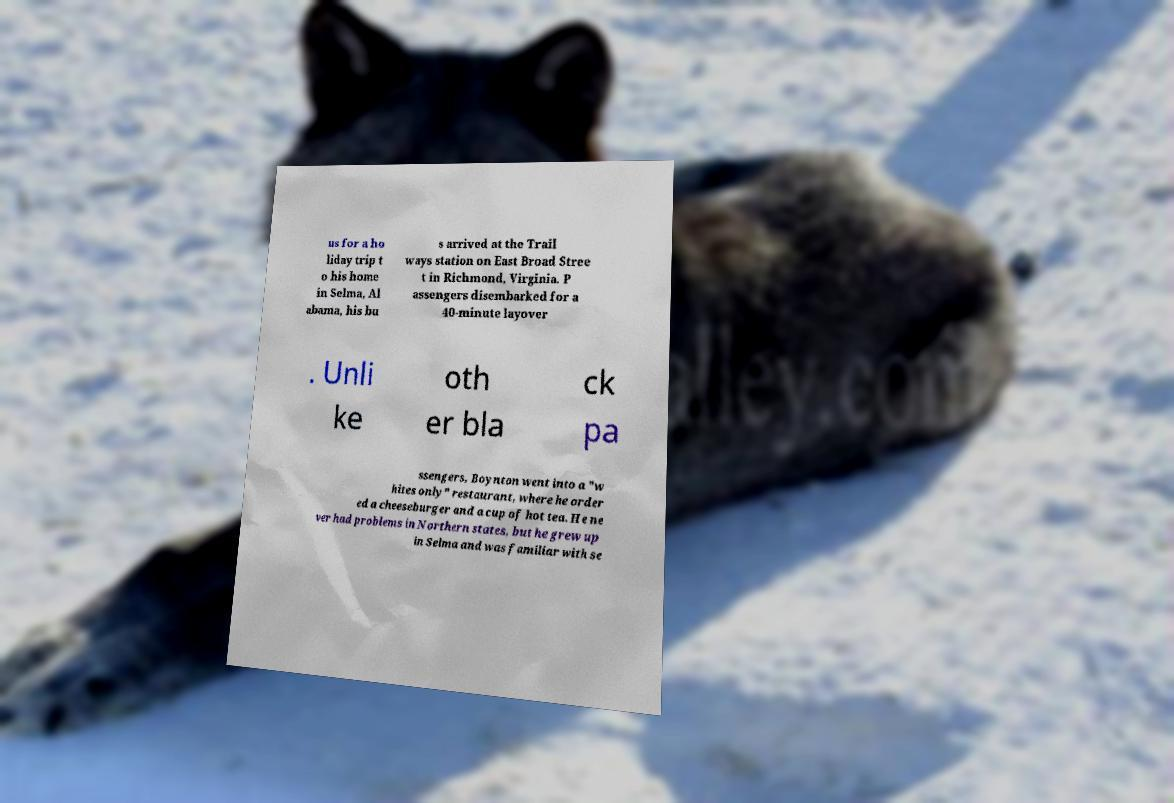Please read and relay the text visible in this image. What does it say? us for a ho liday trip t o his home in Selma, Al abama, his bu s arrived at the Trail ways station on East Broad Stree t in Richmond, Virginia. P assengers disembarked for a 40-minute layover . Unli ke oth er bla ck pa ssengers, Boynton went into a "w hites only" restaurant, where he order ed a cheeseburger and a cup of hot tea. He ne ver had problems in Northern states, but he grew up in Selma and was familiar with se 